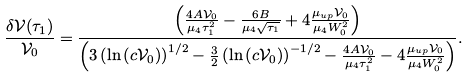Convert formula to latex. <formula><loc_0><loc_0><loc_500><loc_500>\frac { \delta \mathcal { V } ( \tau _ { 1 } ) } { \mathcal { V } _ { 0 } } = \frac { \left ( \frac { 4 A \mathcal { V } _ { 0 } } { \mu _ { 4 } \tau _ { 1 } ^ { 2 } } - \frac { 6 B } { \mu _ { 4 } \sqrt { \tau _ { 1 } } } + 4 \frac { \mu _ { u p } \mathcal { V } _ { 0 } } { \mu _ { 4 } W _ { 0 } ^ { 2 } } \right ) } { \left ( 3 \left ( \ln \left ( c \mathcal { V } _ { 0 } \right ) \right ) ^ { 1 / 2 } - \frac { 3 } { 2 } \left ( \ln \left ( c \mathcal { V } _ { 0 } \right ) \right ) ^ { - 1 / 2 } - \frac { 4 A \mathcal { V } _ { 0 } } { \mu _ { 4 } \tau _ { 1 } ^ { 2 } } - 4 \frac { \mu _ { u p } \mathcal { V } _ { 0 } } { \mu _ { 4 } W _ { 0 } ^ { 2 } } \right ) } .</formula> 